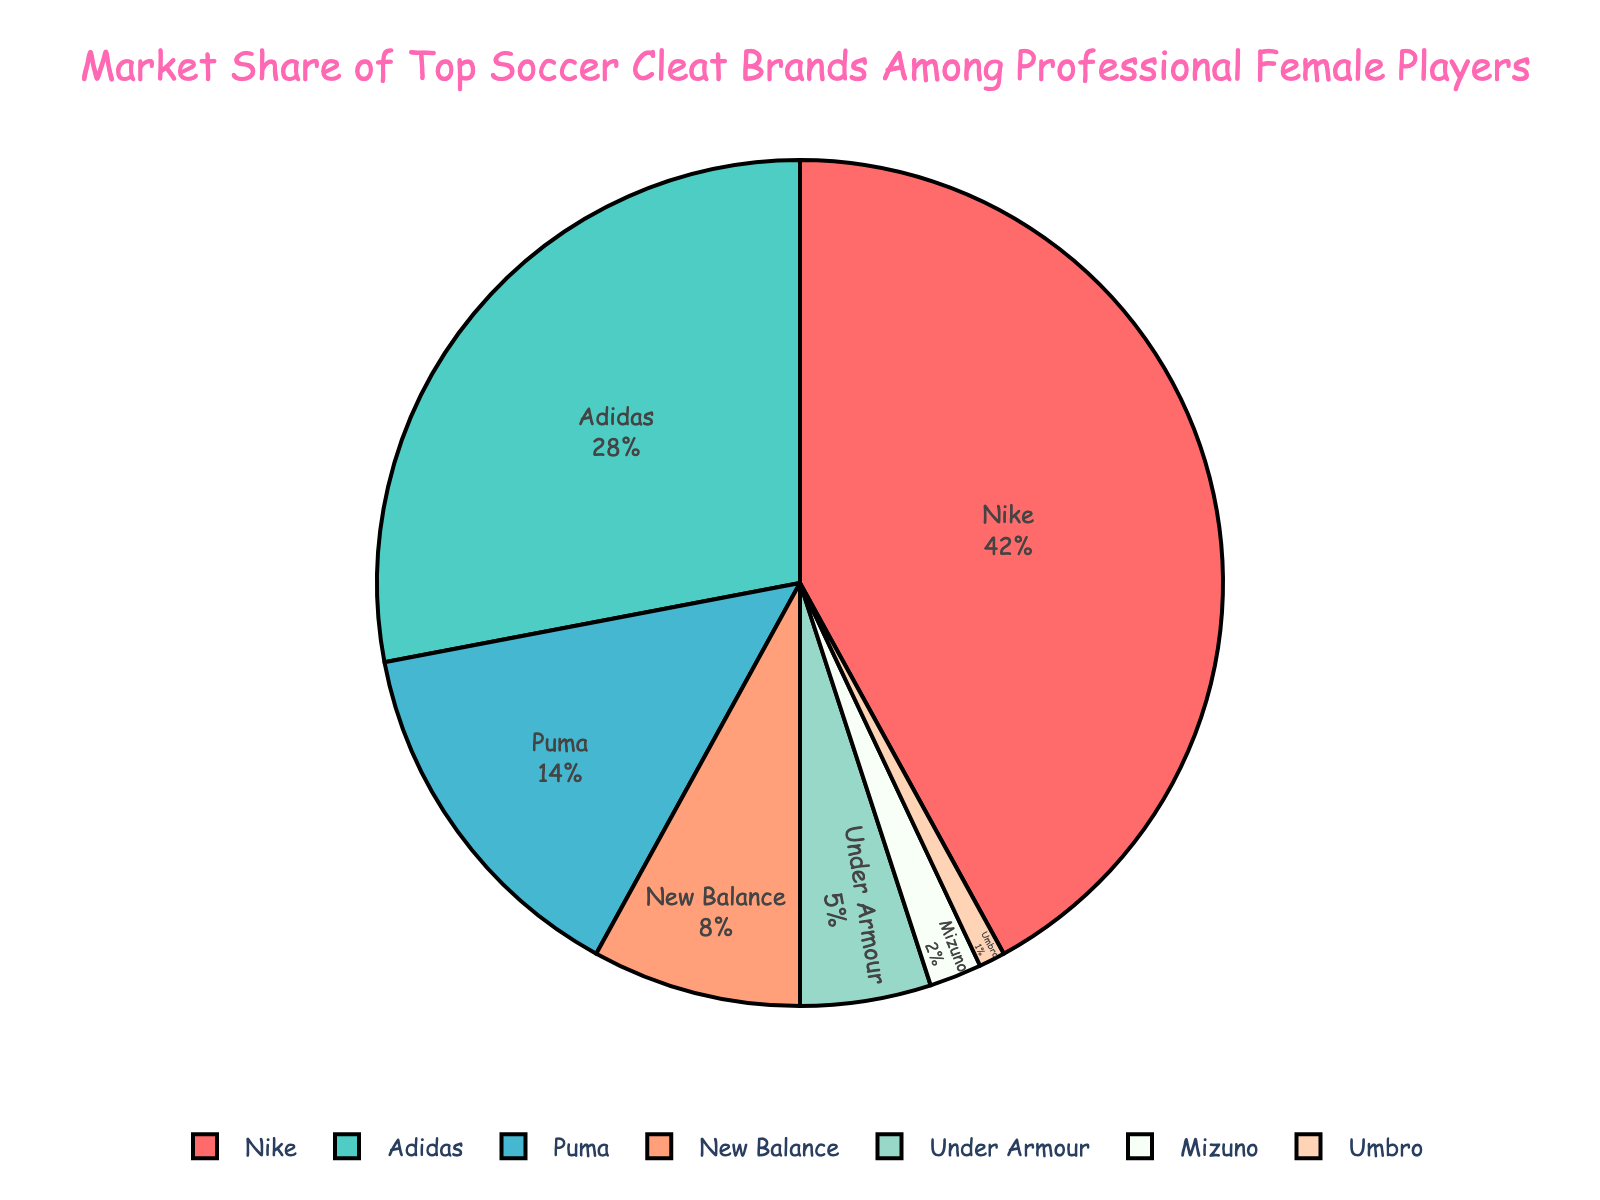What percentage of professional female players use Nike cleats? According to the pie chart, the market share for Nike is 42%. Therefore, 42% of professional female players use Nike cleats.
Answer: 42% Which brand has the second-largest market share and what is its percentage? By looking at the pie chart, the brand with the second-largest market share is Adidas with 28%.
Answer: Adidas, 28% By how much does Nike's market share exceed that of Adidas? Nike's market share is 42% and Adidas' is 28%. The difference can be calculated as 42% - 28% = 14%.
Answer: 14% Is New Balance's market share more than double that of Mizuno's? New Balance's market share is 8%, and Mizuno's is 2%. To check if it is more than double, we compare 8% to 2%*2 = 4%. Since 8% > 4%, New Balance's market share is indeed more than double Mizuno's.
Answer: Yes If you combine the market shares of Mizuno, Umbro, and Under Armour, would their combined share exceed that of Puma? Combining the shares: Mizuno (2%) + Umbro (1%) + Under Armour (5%) = 8%. Comparing to Puma's 14%, 8% < 14%, so they do not exceed Puma's market share.
Answer: No What's the combined market share of the top three brands? Nike (42%) + Adidas (28%) + Puma (14%) = 84%. This is the combined market share of the top three brands.
Answer: 84% Which brand has the smallest market share and what is its percentage? By inspecting the pie chart, the smallest market share belongs to Umbro with 1%.
Answer: Umbro, 1% Is the market share of Adidas closer to Nike's or to Puma's? Adidas has 28%, Nike has 42%, and Puma has 14%. The difference between Adidas and Nike is 42% - 28% = 14%, and the difference between Adidas and Puma is 28% - 14% = 14%. The shares are equally close to both Nike and Puma.
Answer: Equally close What is the percentage difference between New Balance and Under Armour's market share? New Balance's share is 8% and Under Armour's is 5%. The difference is 8% - 5% = 3%.
Answer: 3% What is the total market share of all brands other than Nike? Adding all other brands: Adidas (28%) + Puma (14%) + New Balance (8%) + Under Armour (5%) + Mizuno (2%) + Umbro (1%) = 58%.
Answer: 58% 